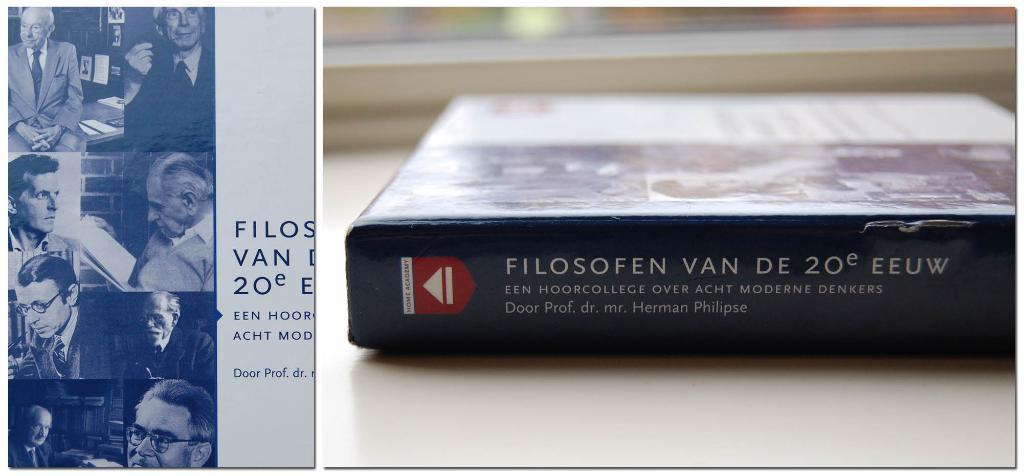<image>
Relay a brief, clear account of the picture shown. The spine of a book titled Filosofen Van De 20 EEUW 